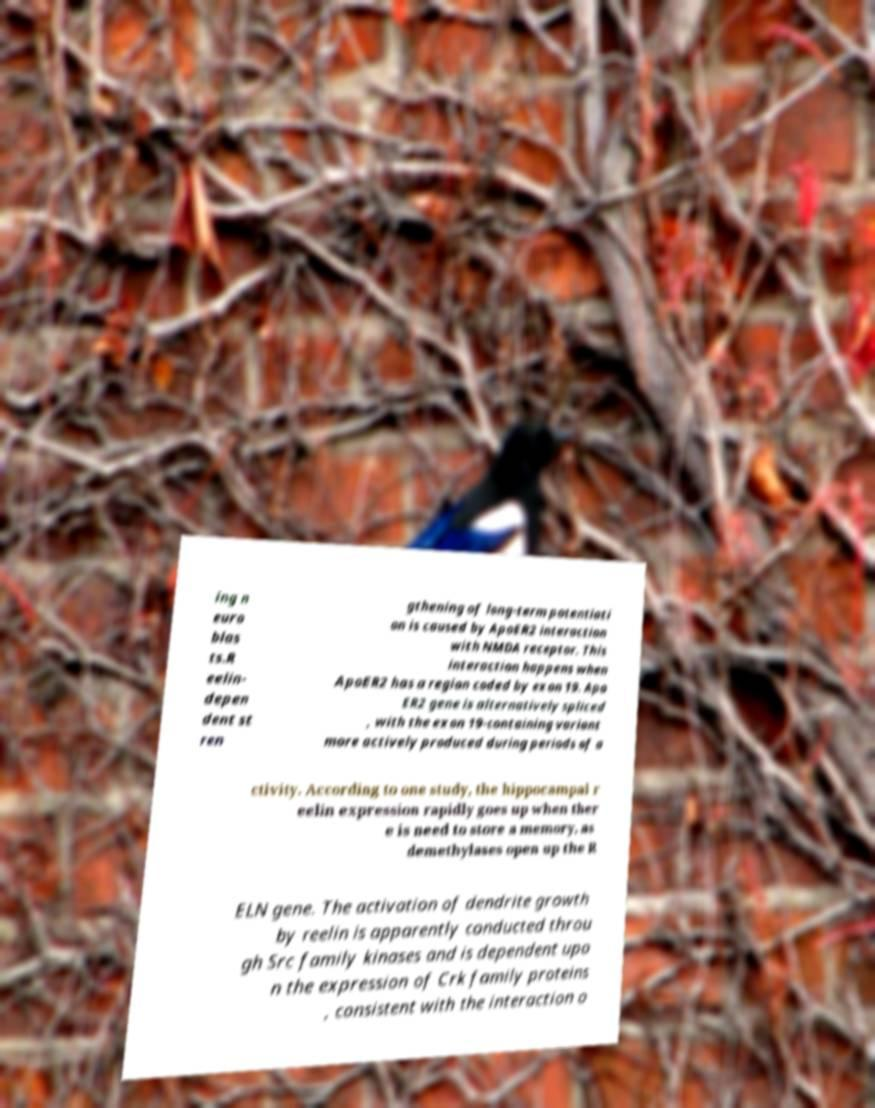What messages or text are displayed in this image? I need them in a readable, typed format. ing n euro blas ts.R eelin- depen dent st ren gthening of long-term potentiati on is caused by ApoER2 interaction with NMDA receptor. This interaction happens when ApoER2 has a region coded by exon 19. Apo ER2 gene is alternatively spliced , with the exon 19-containing variant more actively produced during periods of a ctivity. According to one study, the hippocampal r eelin expression rapidly goes up when ther e is need to store a memory, as demethylases open up the R ELN gene. The activation of dendrite growth by reelin is apparently conducted throu gh Src family kinases and is dependent upo n the expression of Crk family proteins , consistent with the interaction o 